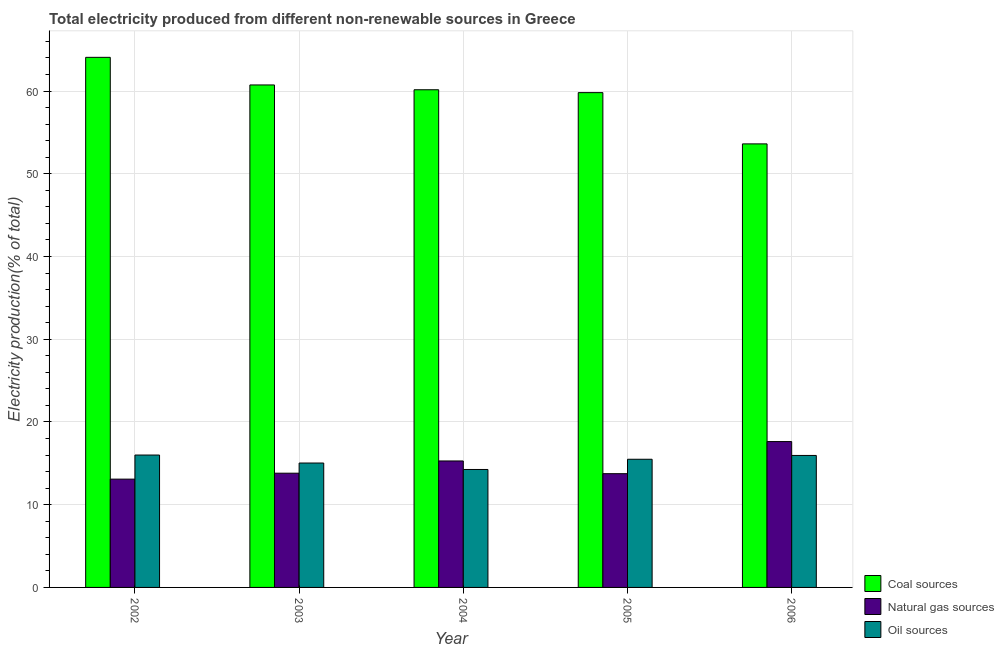How many different coloured bars are there?
Provide a short and direct response. 3. How many groups of bars are there?
Give a very brief answer. 5. Are the number of bars per tick equal to the number of legend labels?
Your answer should be compact. Yes. Are the number of bars on each tick of the X-axis equal?
Your answer should be compact. Yes. What is the label of the 4th group of bars from the left?
Provide a short and direct response. 2005. In how many cases, is the number of bars for a given year not equal to the number of legend labels?
Ensure brevity in your answer.  0. What is the percentage of electricity produced by natural gas in 2006?
Ensure brevity in your answer.  17.63. Across all years, what is the maximum percentage of electricity produced by coal?
Ensure brevity in your answer.  64.08. Across all years, what is the minimum percentage of electricity produced by coal?
Offer a terse response. 53.61. In which year was the percentage of electricity produced by natural gas maximum?
Keep it short and to the point. 2006. In which year was the percentage of electricity produced by coal minimum?
Give a very brief answer. 2006. What is the total percentage of electricity produced by oil sources in the graph?
Your answer should be compact. 76.74. What is the difference between the percentage of electricity produced by oil sources in 2004 and that in 2005?
Make the answer very short. -1.24. What is the difference between the percentage of electricity produced by natural gas in 2006 and the percentage of electricity produced by oil sources in 2005?
Give a very brief answer. 3.88. What is the average percentage of electricity produced by coal per year?
Your answer should be very brief. 59.68. In the year 2005, what is the difference between the percentage of electricity produced by oil sources and percentage of electricity produced by coal?
Provide a short and direct response. 0. In how many years, is the percentage of electricity produced by oil sources greater than 8 %?
Offer a very short reply. 5. What is the ratio of the percentage of electricity produced by oil sources in 2002 to that in 2006?
Provide a short and direct response. 1. Is the percentage of electricity produced by natural gas in 2003 less than that in 2006?
Offer a terse response. Yes. Is the difference between the percentage of electricity produced by natural gas in 2002 and 2004 greater than the difference between the percentage of electricity produced by oil sources in 2002 and 2004?
Provide a short and direct response. No. What is the difference between the highest and the second highest percentage of electricity produced by oil sources?
Keep it short and to the point. 0.05. What is the difference between the highest and the lowest percentage of electricity produced by coal?
Keep it short and to the point. 10.46. What does the 2nd bar from the left in 2002 represents?
Ensure brevity in your answer.  Natural gas sources. What does the 2nd bar from the right in 2006 represents?
Your response must be concise. Natural gas sources. Is it the case that in every year, the sum of the percentage of electricity produced by coal and percentage of electricity produced by natural gas is greater than the percentage of electricity produced by oil sources?
Keep it short and to the point. Yes. Are all the bars in the graph horizontal?
Keep it short and to the point. No. How many years are there in the graph?
Keep it short and to the point. 5. Are the values on the major ticks of Y-axis written in scientific E-notation?
Your response must be concise. No. Does the graph contain any zero values?
Offer a terse response. No. How many legend labels are there?
Offer a terse response. 3. What is the title of the graph?
Provide a succinct answer. Total electricity produced from different non-renewable sources in Greece. What is the label or title of the X-axis?
Provide a short and direct response. Year. What is the Electricity production(% of total) of Coal sources in 2002?
Make the answer very short. 64.08. What is the Electricity production(% of total) of Natural gas sources in 2002?
Provide a succinct answer. 13.09. What is the Electricity production(% of total) of Oil sources in 2002?
Ensure brevity in your answer.  16. What is the Electricity production(% of total) of Coal sources in 2003?
Provide a short and direct response. 60.74. What is the Electricity production(% of total) in Natural gas sources in 2003?
Make the answer very short. 13.81. What is the Electricity production(% of total) in Oil sources in 2003?
Your answer should be very brief. 15.04. What is the Electricity production(% of total) of Coal sources in 2004?
Offer a very short reply. 60.16. What is the Electricity production(% of total) in Natural gas sources in 2004?
Your answer should be compact. 15.29. What is the Electricity production(% of total) of Oil sources in 2004?
Your answer should be very brief. 14.26. What is the Electricity production(% of total) in Coal sources in 2005?
Your answer should be very brief. 59.81. What is the Electricity production(% of total) of Natural gas sources in 2005?
Offer a terse response. 13.75. What is the Electricity production(% of total) in Oil sources in 2005?
Your response must be concise. 15.49. What is the Electricity production(% of total) in Coal sources in 2006?
Your response must be concise. 53.61. What is the Electricity production(% of total) in Natural gas sources in 2006?
Ensure brevity in your answer.  17.63. What is the Electricity production(% of total) of Oil sources in 2006?
Give a very brief answer. 15.95. Across all years, what is the maximum Electricity production(% of total) of Coal sources?
Your answer should be compact. 64.08. Across all years, what is the maximum Electricity production(% of total) of Natural gas sources?
Your answer should be very brief. 17.63. Across all years, what is the maximum Electricity production(% of total) in Oil sources?
Offer a very short reply. 16. Across all years, what is the minimum Electricity production(% of total) in Coal sources?
Your answer should be very brief. 53.61. Across all years, what is the minimum Electricity production(% of total) in Natural gas sources?
Offer a terse response. 13.09. Across all years, what is the minimum Electricity production(% of total) in Oil sources?
Offer a terse response. 14.26. What is the total Electricity production(% of total) of Coal sources in the graph?
Your answer should be compact. 298.39. What is the total Electricity production(% of total) of Natural gas sources in the graph?
Keep it short and to the point. 73.56. What is the total Electricity production(% of total) of Oil sources in the graph?
Offer a very short reply. 76.74. What is the difference between the Electricity production(% of total) in Coal sources in 2002 and that in 2003?
Offer a terse response. 3.34. What is the difference between the Electricity production(% of total) in Natural gas sources in 2002 and that in 2003?
Your answer should be compact. -0.72. What is the difference between the Electricity production(% of total) in Oil sources in 2002 and that in 2003?
Offer a terse response. 0.97. What is the difference between the Electricity production(% of total) in Coal sources in 2002 and that in 2004?
Your response must be concise. 3.92. What is the difference between the Electricity production(% of total) of Natural gas sources in 2002 and that in 2004?
Provide a succinct answer. -2.2. What is the difference between the Electricity production(% of total) in Oil sources in 2002 and that in 2004?
Ensure brevity in your answer.  1.75. What is the difference between the Electricity production(% of total) of Coal sources in 2002 and that in 2005?
Offer a very short reply. 4.27. What is the difference between the Electricity production(% of total) of Natural gas sources in 2002 and that in 2005?
Your answer should be very brief. -0.66. What is the difference between the Electricity production(% of total) of Oil sources in 2002 and that in 2005?
Make the answer very short. 0.51. What is the difference between the Electricity production(% of total) in Coal sources in 2002 and that in 2006?
Provide a short and direct response. 10.46. What is the difference between the Electricity production(% of total) of Natural gas sources in 2002 and that in 2006?
Offer a terse response. -4.54. What is the difference between the Electricity production(% of total) of Oil sources in 2002 and that in 2006?
Your answer should be very brief. 0.05. What is the difference between the Electricity production(% of total) of Coal sources in 2003 and that in 2004?
Make the answer very short. 0.58. What is the difference between the Electricity production(% of total) of Natural gas sources in 2003 and that in 2004?
Make the answer very short. -1.48. What is the difference between the Electricity production(% of total) of Oil sources in 2003 and that in 2004?
Provide a short and direct response. 0.78. What is the difference between the Electricity production(% of total) of Coal sources in 2003 and that in 2005?
Offer a terse response. 0.93. What is the difference between the Electricity production(% of total) in Natural gas sources in 2003 and that in 2005?
Make the answer very short. 0.06. What is the difference between the Electricity production(% of total) of Oil sources in 2003 and that in 2005?
Provide a short and direct response. -0.46. What is the difference between the Electricity production(% of total) in Coal sources in 2003 and that in 2006?
Give a very brief answer. 7.12. What is the difference between the Electricity production(% of total) in Natural gas sources in 2003 and that in 2006?
Make the answer very short. -3.82. What is the difference between the Electricity production(% of total) in Oil sources in 2003 and that in 2006?
Ensure brevity in your answer.  -0.92. What is the difference between the Electricity production(% of total) of Coal sources in 2004 and that in 2005?
Offer a very short reply. 0.35. What is the difference between the Electricity production(% of total) in Natural gas sources in 2004 and that in 2005?
Provide a short and direct response. 1.54. What is the difference between the Electricity production(% of total) of Oil sources in 2004 and that in 2005?
Offer a terse response. -1.24. What is the difference between the Electricity production(% of total) in Coal sources in 2004 and that in 2006?
Your answer should be compact. 6.54. What is the difference between the Electricity production(% of total) of Natural gas sources in 2004 and that in 2006?
Provide a short and direct response. -2.34. What is the difference between the Electricity production(% of total) in Oil sources in 2004 and that in 2006?
Make the answer very short. -1.7. What is the difference between the Electricity production(% of total) of Coal sources in 2005 and that in 2006?
Provide a succinct answer. 6.2. What is the difference between the Electricity production(% of total) of Natural gas sources in 2005 and that in 2006?
Keep it short and to the point. -3.88. What is the difference between the Electricity production(% of total) of Oil sources in 2005 and that in 2006?
Provide a short and direct response. -0.46. What is the difference between the Electricity production(% of total) of Coal sources in 2002 and the Electricity production(% of total) of Natural gas sources in 2003?
Keep it short and to the point. 50.27. What is the difference between the Electricity production(% of total) of Coal sources in 2002 and the Electricity production(% of total) of Oil sources in 2003?
Offer a terse response. 49.04. What is the difference between the Electricity production(% of total) of Natural gas sources in 2002 and the Electricity production(% of total) of Oil sources in 2003?
Make the answer very short. -1.95. What is the difference between the Electricity production(% of total) in Coal sources in 2002 and the Electricity production(% of total) in Natural gas sources in 2004?
Provide a short and direct response. 48.79. What is the difference between the Electricity production(% of total) of Coal sources in 2002 and the Electricity production(% of total) of Oil sources in 2004?
Offer a very short reply. 49.82. What is the difference between the Electricity production(% of total) in Natural gas sources in 2002 and the Electricity production(% of total) in Oil sources in 2004?
Make the answer very short. -1.17. What is the difference between the Electricity production(% of total) of Coal sources in 2002 and the Electricity production(% of total) of Natural gas sources in 2005?
Ensure brevity in your answer.  50.33. What is the difference between the Electricity production(% of total) in Coal sources in 2002 and the Electricity production(% of total) in Oil sources in 2005?
Keep it short and to the point. 48.58. What is the difference between the Electricity production(% of total) in Natural gas sources in 2002 and the Electricity production(% of total) in Oil sources in 2005?
Keep it short and to the point. -2.4. What is the difference between the Electricity production(% of total) of Coal sources in 2002 and the Electricity production(% of total) of Natural gas sources in 2006?
Offer a very short reply. 46.45. What is the difference between the Electricity production(% of total) in Coal sources in 2002 and the Electricity production(% of total) in Oil sources in 2006?
Keep it short and to the point. 48.12. What is the difference between the Electricity production(% of total) of Natural gas sources in 2002 and the Electricity production(% of total) of Oil sources in 2006?
Provide a short and direct response. -2.86. What is the difference between the Electricity production(% of total) of Coal sources in 2003 and the Electricity production(% of total) of Natural gas sources in 2004?
Your answer should be compact. 45.45. What is the difference between the Electricity production(% of total) of Coal sources in 2003 and the Electricity production(% of total) of Oil sources in 2004?
Your answer should be compact. 46.48. What is the difference between the Electricity production(% of total) in Natural gas sources in 2003 and the Electricity production(% of total) in Oil sources in 2004?
Provide a succinct answer. -0.45. What is the difference between the Electricity production(% of total) of Coal sources in 2003 and the Electricity production(% of total) of Natural gas sources in 2005?
Your answer should be very brief. 46.99. What is the difference between the Electricity production(% of total) of Coal sources in 2003 and the Electricity production(% of total) of Oil sources in 2005?
Offer a very short reply. 45.24. What is the difference between the Electricity production(% of total) in Natural gas sources in 2003 and the Electricity production(% of total) in Oil sources in 2005?
Offer a very short reply. -1.69. What is the difference between the Electricity production(% of total) in Coal sources in 2003 and the Electricity production(% of total) in Natural gas sources in 2006?
Offer a terse response. 43.11. What is the difference between the Electricity production(% of total) in Coal sources in 2003 and the Electricity production(% of total) in Oil sources in 2006?
Make the answer very short. 44.78. What is the difference between the Electricity production(% of total) of Natural gas sources in 2003 and the Electricity production(% of total) of Oil sources in 2006?
Give a very brief answer. -2.15. What is the difference between the Electricity production(% of total) in Coal sources in 2004 and the Electricity production(% of total) in Natural gas sources in 2005?
Give a very brief answer. 46.41. What is the difference between the Electricity production(% of total) in Coal sources in 2004 and the Electricity production(% of total) in Oil sources in 2005?
Provide a short and direct response. 44.66. What is the difference between the Electricity production(% of total) in Natural gas sources in 2004 and the Electricity production(% of total) in Oil sources in 2005?
Give a very brief answer. -0.21. What is the difference between the Electricity production(% of total) of Coal sources in 2004 and the Electricity production(% of total) of Natural gas sources in 2006?
Your response must be concise. 42.53. What is the difference between the Electricity production(% of total) in Coal sources in 2004 and the Electricity production(% of total) in Oil sources in 2006?
Give a very brief answer. 44.2. What is the difference between the Electricity production(% of total) in Natural gas sources in 2004 and the Electricity production(% of total) in Oil sources in 2006?
Keep it short and to the point. -0.67. What is the difference between the Electricity production(% of total) in Coal sources in 2005 and the Electricity production(% of total) in Natural gas sources in 2006?
Provide a succinct answer. 42.18. What is the difference between the Electricity production(% of total) in Coal sources in 2005 and the Electricity production(% of total) in Oil sources in 2006?
Your answer should be very brief. 43.86. What is the difference between the Electricity production(% of total) of Natural gas sources in 2005 and the Electricity production(% of total) of Oil sources in 2006?
Provide a succinct answer. -2.2. What is the average Electricity production(% of total) in Coal sources per year?
Your answer should be very brief. 59.68. What is the average Electricity production(% of total) of Natural gas sources per year?
Offer a very short reply. 14.71. What is the average Electricity production(% of total) of Oil sources per year?
Ensure brevity in your answer.  15.35. In the year 2002, what is the difference between the Electricity production(% of total) in Coal sources and Electricity production(% of total) in Natural gas sources?
Provide a succinct answer. 50.99. In the year 2002, what is the difference between the Electricity production(% of total) of Coal sources and Electricity production(% of total) of Oil sources?
Offer a terse response. 48.07. In the year 2002, what is the difference between the Electricity production(% of total) in Natural gas sources and Electricity production(% of total) in Oil sources?
Provide a succinct answer. -2.91. In the year 2003, what is the difference between the Electricity production(% of total) in Coal sources and Electricity production(% of total) in Natural gas sources?
Ensure brevity in your answer.  46.93. In the year 2003, what is the difference between the Electricity production(% of total) of Coal sources and Electricity production(% of total) of Oil sources?
Your answer should be compact. 45.7. In the year 2003, what is the difference between the Electricity production(% of total) in Natural gas sources and Electricity production(% of total) in Oil sources?
Give a very brief answer. -1.23. In the year 2004, what is the difference between the Electricity production(% of total) of Coal sources and Electricity production(% of total) of Natural gas sources?
Offer a very short reply. 44.87. In the year 2004, what is the difference between the Electricity production(% of total) in Coal sources and Electricity production(% of total) in Oil sources?
Your answer should be compact. 45.9. In the year 2004, what is the difference between the Electricity production(% of total) of Natural gas sources and Electricity production(% of total) of Oil sources?
Your answer should be compact. 1.03. In the year 2005, what is the difference between the Electricity production(% of total) of Coal sources and Electricity production(% of total) of Natural gas sources?
Offer a terse response. 46.06. In the year 2005, what is the difference between the Electricity production(% of total) of Coal sources and Electricity production(% of total) of Oil sources?
Your response must be concise. 44.32. In the year 2005, what is the difference between the Electricity production(% of total) in Natural gas sources and Electricity production(% of total) in Oil sources?
Your answer should be very brief. -1.74. In the year 2006, what is the difference between the Electricity production(% of total) in Coal sources and Electricity production(% of total) in Natural gas sources?
Provide a succinct answer. 35.98. In the year 2006, what is the difference between the Electricity production(% of total) of Coal sources and Electricity production(% of total) of Oil sources?
Offer a very short reply. 37.66. In the year 2006, what is the difference between the Electricity production(% of total) in Natural gas sources and Electricity production(% of total) in Oil sources?
Give a very brief answer. 1.68. What is the ratio of the Electricity production(% of total) in Coal sources in 2002 to that in 2003?
Offer a very short reply. 1.05. What is the ratio of the Electricity production(% of total) in Natural gas sources in 2002 to that in 2003?
Provide a succinct answer. 0.95. What is the ratio of the Electricity production(% of total) in Oil sources in 2002 to that in 2003?
Your answer should be compact. 1.06. What is the ratio of the Electricity production(% of total) of Coal sources in 2002 to that in 2004?
Your answer should be compact. 1.07. What is the ratio of the Electricity production(% of total) of Natural gas sources in 2002 to that in 2004?
Make the answer very short. 0.86. What is the ratio of the Electricity production(% of total) in Oil sources in 2002 to that in 2004?
Make the answer very short. 1.12. What is the ratio of the Electricity production(% of total) of Coal sources in 2002 to that in 2005?
Offer a very short reply. 1.07. What is the ratio of the Electricity production(% of total) in Natural gas sources in 2002 to that in 2005?
Your response must be concise. 0.95. What is the ratio of the Electricity production(% of total) of Oil sources in 2002 to that in 2005?
Give a very brief answer. 1.03. What is the ratio of the Electricity production(% of total) in Coal sources in 2002 to that in 2006?
Your answer should be compact. 1.2. What is the ratio of the Electricity production(% of total) in Natural gas sources in 2002 to that in 2006?
Provide a short and direct response. 0.74. What is the ratio of the Electricity production(% of total) of Coal sources in 2003 to that in 2004?
Your answer should be compact. 1.01. What is the ratio of the Electricity production(% of total) in Natural gas sources in 2003 to that in 2004?
Provide a short and direct response. 0.9. What is the ratio of the Electricity production(% of total) in Oil sources in 2003 to that in 2004?
Your response must be concise. 1.05. What is the ratio of the Electricity production(% of total) in Coal sources in 2003 to that in 2005?
Your answer should be compact. 1.02. What is the ratio of the Electricity production(% of total) in Natural gas sources in 2003 to that in 2005?
Your answer should be compact. 1. What is the ratio of the Electricity production(% of total) in Oil sources in 2003 to that in 2005?
Make the answer very short. 0.97. What is the ratio of the Electricity production(% of total) in Coal sources in 2003 to that in 2006?
Your answer should be compact. 1.13. What is the ratio of the Electricity production(% of total) of Natural gas sources in 2003 to that in 2006?
Your answer should be very brief. 0.78. What is the ratio of the Electricity production(% of total) of Oil sources in 2003 to that in 2006?
Your answer should be very brief. 0.94. What is the ratio of the Electricity production(% of total) of Natural gas sources in 2004 to that in 2005?
Offer a very short reply. 1.11. What is the ratio of the Electricity production(% of total) in Oil sources in 2004 to that in 2005?
Offer a very short reply. 0.92. What is the ratio of the Electricity production(% of total) in Coal sources in 2004 to that in 2006?
Your answer should be compact. 1.12. What is the ratio of the Electricity production(% of total) in Natural gas sources in 2004 to that in 2006?
Your answer should be very brief. 0.87. What is the ratio of the Electricity production(% of total) in Oil sources in 2004 to that in 2006?
Your answer should be very brief. 0.89. What is the ratio of the Electricity production(% of total) in Coal sources in 2005 to that in 2006?
Your response must be concise. 1.12. What is the ratio of the Electricity production(% of total) in Natural gas sources in 2005 to that in 2006?
Offer a very short reply. 0.78. What is the ratio of the Electricity production(% of total) in Oil sources in 2005 to that in 2006?
Your response must be concise. 0.97. What is the difference between the highest and the second highest Electricity production(% of total) of Coal sources?
Provide a succinct answer. 3.34. What is the difference between the highest and the second highest Electricity production(% of total) of Natural gas sources?
Offer a very short reply. 2.34. What is the difference between the highest and the second highest Electricity production(% of total) in Oil sources?
Your answer should be very brief. 0.05. What is the difference between the highest and the lowest Electricity production(% of total) in Coal sources?
Your answer should be compact. 10.46. What is the difference between the highest and the lowest Electricity production(% of total) in Natural gas sources?
Give a very brief answer. 4.54. What is the difference between the highest and the lowest Electricity production(% of total) of Oil sources?
Your answer should be very brief. 1.75. 